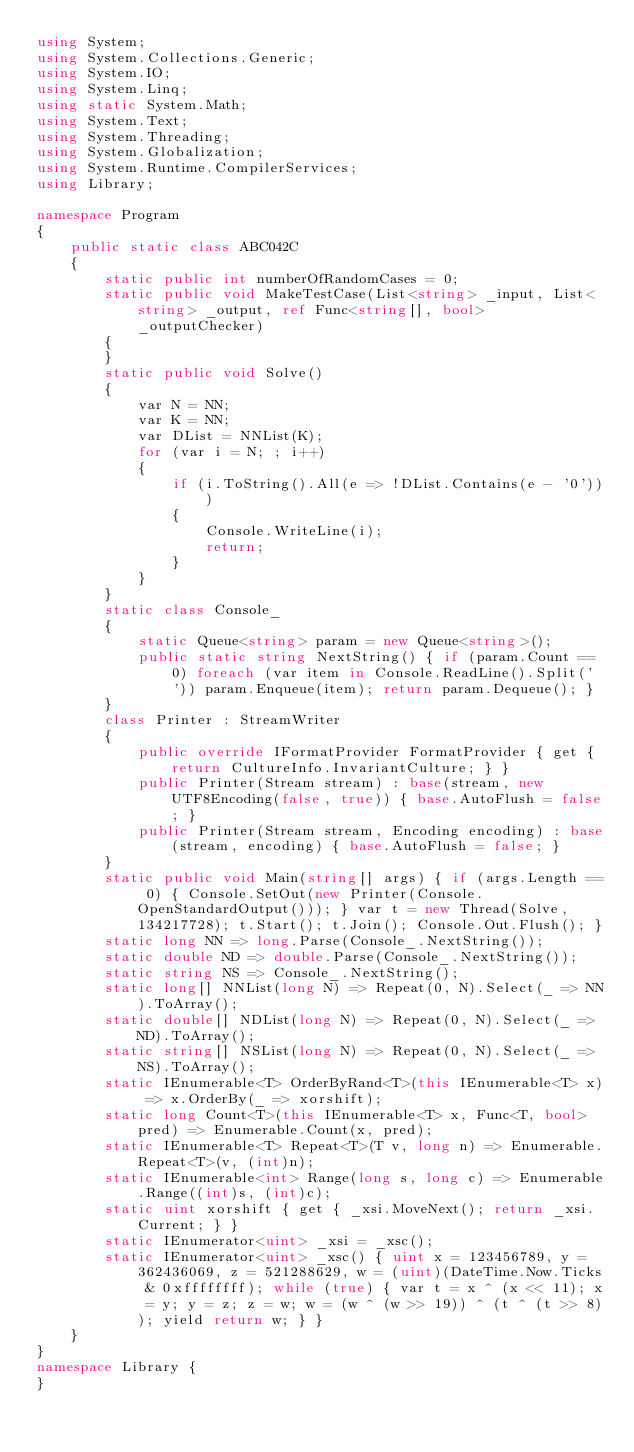Convert code to text. <code><loc_0><loc_0><loc_500><loc_500><_C#_>using System;
using System.Collections.Generic;
using System.IO;
using System.Linq;
using static System.Math;
using System.Text;
using System.Threading;
using System.Globalization;
using System.Runtime.CompilerServices;
using Library;

namespace Program
{
    public static class ABC042C
    {
        static public int numberOfRandomCases = 0;
        static public void MakeTestCase(List<string> _input, List<string> _output, ref Func<string[], bool> _outputChecker)
        {
        }
        static public void Solve()
        {
            var N = NN;
            var K = NN;
            var DList = NNList(K);
            for (var i = N; ; i++)
            {
                if (i.ToString().All(e => !DList.Contains(e - '0')))
                {
                    Console.WriteLine(i);
                    return;
                }
            }
        }
        static class Console_
        {
            static Queue<string> param = new Queue<string>();
            public static string NextString() { if (param.Count == 0) foreach (var item in Console.ReadLine().Split(' ')) param.Enqueue(item); return param.Dequeue(); }
        }
        class Printer : StreamWriter
        {
            public override IFormatProvider FormatProvider { get { return CultureInfo.InvariantCulture; } }
            public Printer(Stream stream) : base(stream, new UTF8Encoding(false, true)) { base.AutoFlush = false; }
            public Printer(Stream stream, Encoding encoding) : base(stream, encoding) { base.AutoFlush = false; }
        }
        static public void Main(string[] args) { if (args.Length == 0) { Console.SetOut(new Printer(Console.OpenStandardOutput())); } var t = new Thread(Solve, 134217728); t.Start(); t.Join(); Console.Out.Flush(); }
        static long NN => long.Parse(Console_.NextString());
        static double ND => double.Parse(Console_.NextString());
        static string NS => Console_.NextString();
        static long[] NNList(long N) => Repeat(0, N).Select(_ => NN).ToArray();
        static double[] NDList(long N) => Repeat(0, N).Select(_ => ND).ToArray();
        static string[] NSList(long N) => Repeat(0, N).Select(_ => NS).ToArray();
        static IEnumerable<T> OrderByRand<T>(this IEnumerable<T> x) => x.OrderBy(_ => xorshift);
        static long Count<T>(this IEnumerable<T> x, Func<T, bool> pred) => Enumerable.Count(x, pred);
        static IEnumerable<T> Repeat<T>(T v, long n) => Enumerable.Repeat<T>(v, (int)n);
        static IEnumerable<int> Range(long s, long c) => Enumerable.Range((int)s, (int)c);
        static uint xorshift { get { _xsi.MoveNext(); return _xsi.Current; } }
        static IEnumerator<uint> _xsi = _xsc();
        static IEnumerator<uint> _xsc() { uint x = 123456789, y = 362436069, z = 521288629, w = (uint)(DateTime.Now.Ticks & 0xffffffff); while (true) { var t = x ^ (x << 11); x = y; y = z; z = w; w = (w ^ (w >> 19)) ^ (t ^ (t >> 8)); yield return w; } }
    }
}
namespace Library {
}
</code> 